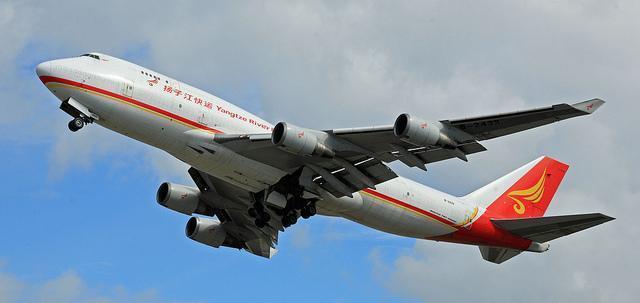How many jets does the plane have?
Give a very brief answer. 4. 